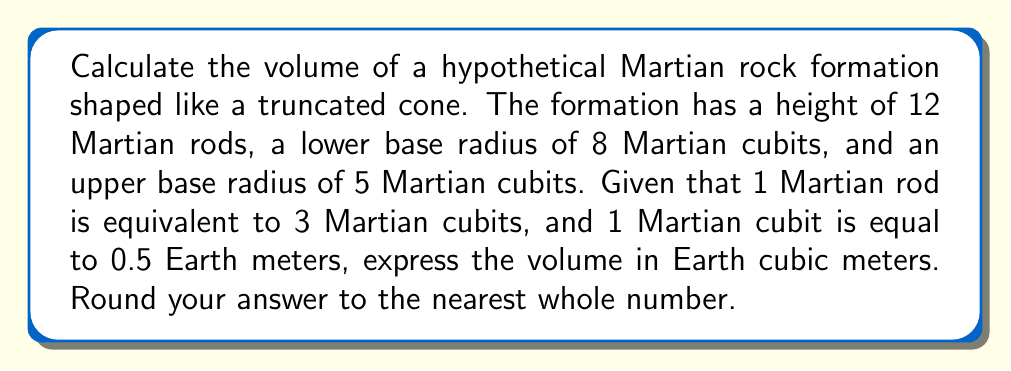Give your solution to this math problem. To solve this problem, we'll follow these steps:

1) First, let's convert all measurements to Martian cubits:
   Height = 12 Martian rods = 12 * 3 = 36 Martian cubits
   Lower base radius = 8 Martian cubits
   Upper base radius = 5 Martian cubits

2) The volume of a truncated cone is given by the formula:

   $$V = \frac{1}{3}\pi h(R^2 + r^2 + Rr)$$

   Where:
   $h$ = height
   $R$ = radius of the lower base
   $r$ = radius of the upper base

3) Substituting our values:

   $$V = \frac{1}{3}\pi * 36(8^2 + 5^2 + 8*5)$$

4) Simplifying:

   $$V = 12\pi(64 + 25 + 40)$$
   $$V = 12\pi(129)$$
   $$V = 1548\pi$$

5) This gives us the volume in Martian cubic cubits. To convert to Earth cubic meters:
   1 Martian cubit = 0.5 Earth meters
   So, 1 Martian cubic cubit = $(0.5)^3 = 0.125$ Earth cubic meters

6) Therefore:
   $$V_{Earth} = 1548\pi * 0.125 \approx 607.35$$

7) Rounding to the nearest whole number:
   $$V_{Earth} \approx 607$$ cubic meters
Answer: 607 cubic meters 